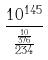Convert formula to latex. <formula><loc_0><loc_0><loc_500><loc_500>\frac { 1 0 ^ { 1 4 5 } } { \frac { \frac { 1 0 } { 3 7 6 } } { 2 3 4 } }</formula> 